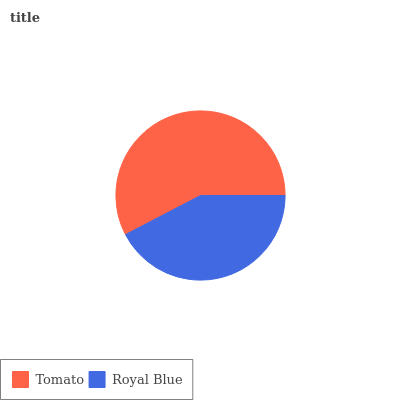Is Royal Blue the minimum?
Answer yes or no. Yes. Is Tomato the maximum?
Answer yes or no. Yes. Is Royal Blue the maximum?
Answer yes or no. No. Is Tomato greater than Royal Blue?
Answer yes or no. Yes. Is Royal Blue less than Tomato?
Answer yes or no. Yes. Is Royal Blue greater than Tomato?
Answer yes or no. No. Is Tomato less than Royal Blue?
Answer yes or no. No. Is Tomato the high median?
Answer yes or no. Yes. Is Royal Blue the low median?
Answer yes or no. Yes. Is Royal Blue the high median?
Answer yes or no. No. Is Tomato the low median?
Answer yes or no. No. 